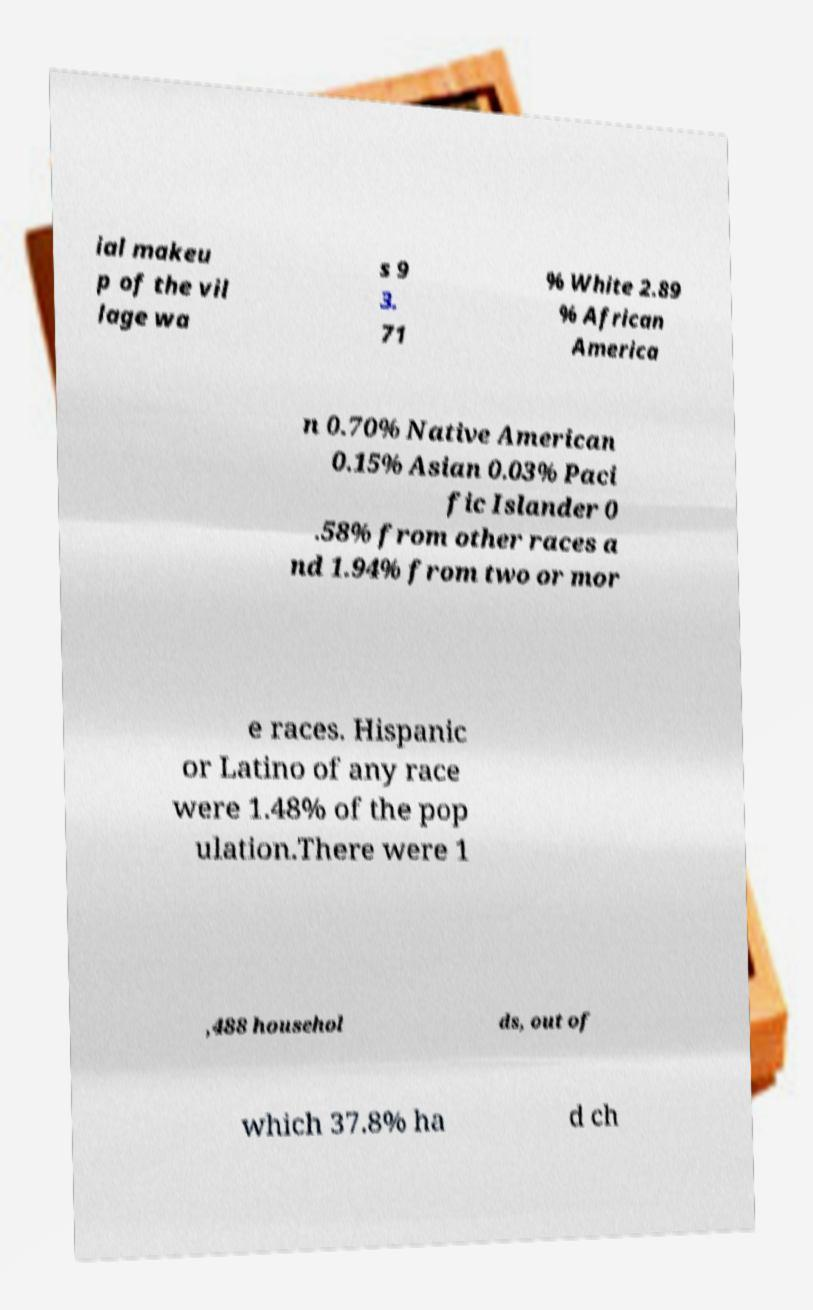Please identify and transcribe the text found in this image. ial makeu p of the vil lage wa s 9 3. 71 % White 2.89 % African America n 0.70% Native American 0.15% Asian 0.03% Paci fic Islander 0 .58% from other races a nd 1.94% from two or mor e races. Hispanic or Latino of any race were 1.48% of the pop ulation.There were 1 ,488 househol ds, out of which 37.8% ha d ch 